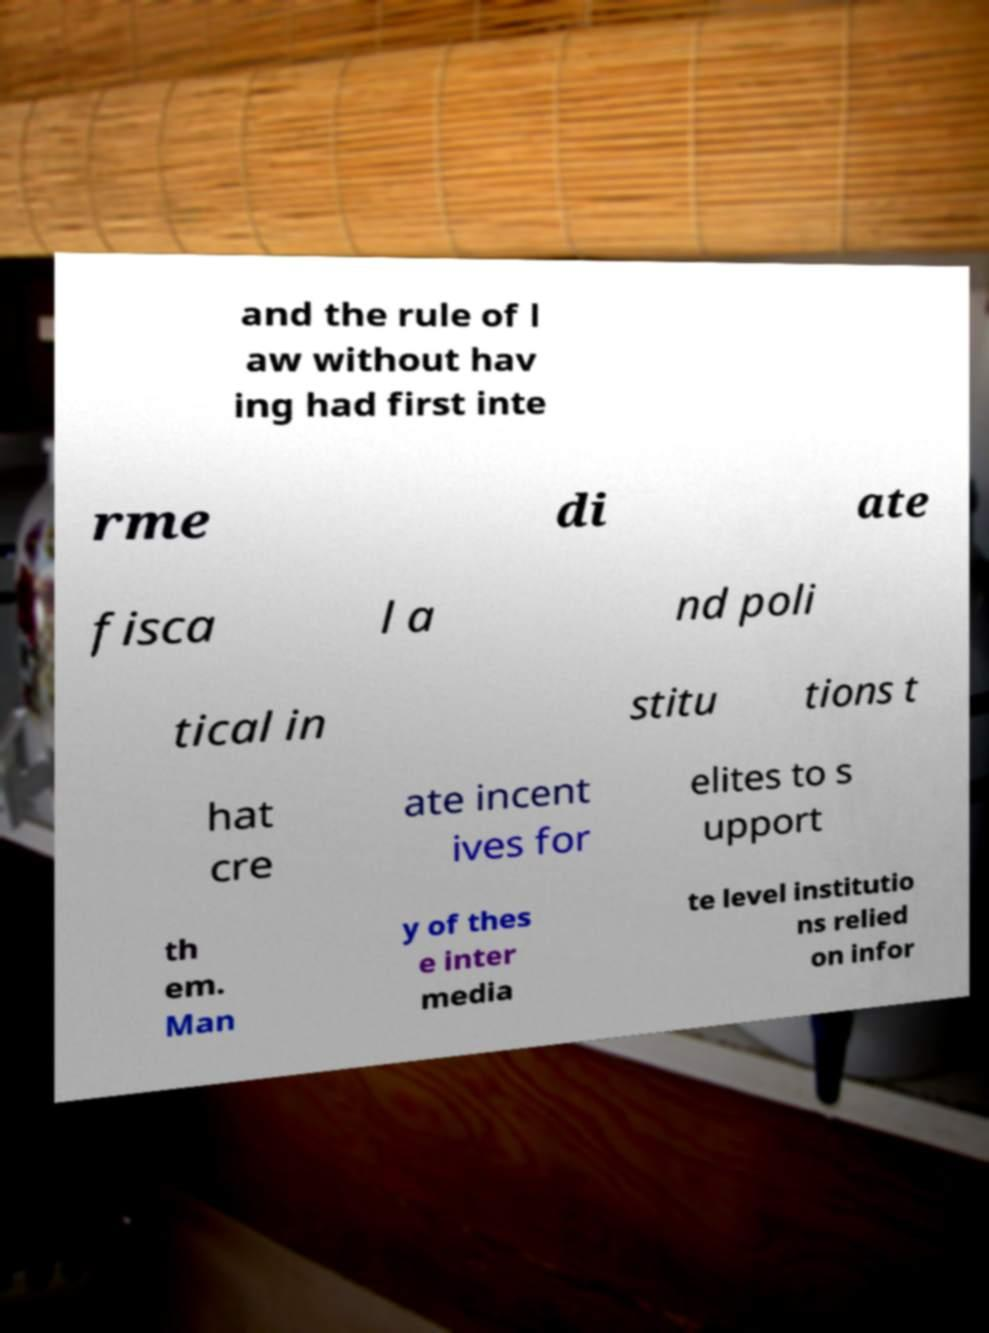There's text embedded in this image that I need extracted. Can you transcribe it verbatim? and the rule of l aw without hav ing had first inte rme di ate fisca l a nd poli tical in stitu tions t hat cre ate incent ives for elites to s upport th em. Man y of thes e inter media te level institutio ns relied on infor 